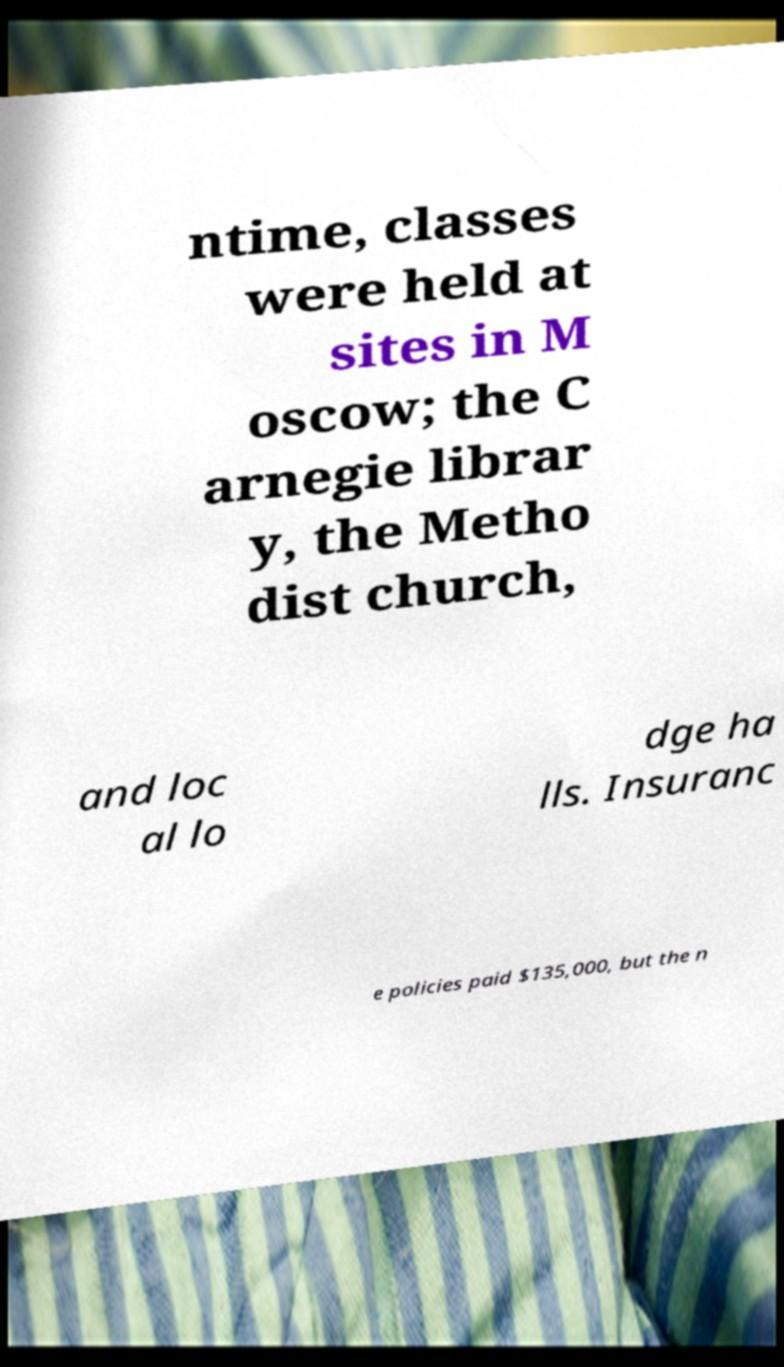Can you read and provide the text displayed in the image?This photo seems to have some interesting text. Can you extract and type it out for me? ntime, classes were held at sites in M oscow; the C arnegie librar y, the Metho dist church, and loc al lo dge ha lls. Insuranc e policies paid $135,000, but the n 